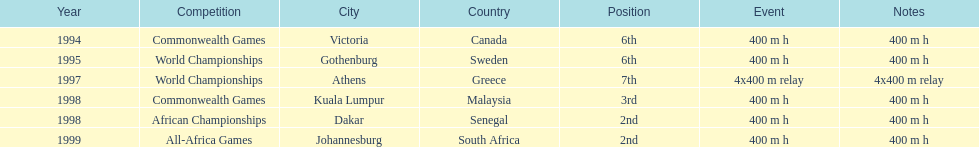Which year had the most competitions? 1998. 